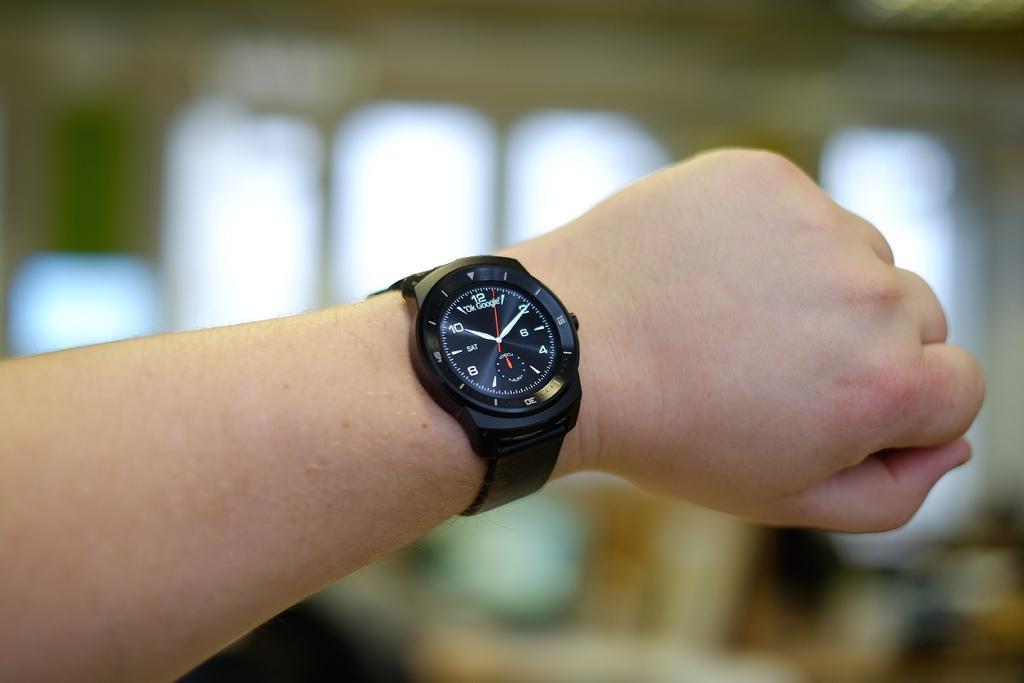Please provide a concise description of this image. In this image we can see a person's hand and there is a watch to the hand. In the background the image is blur but we can see objects. 